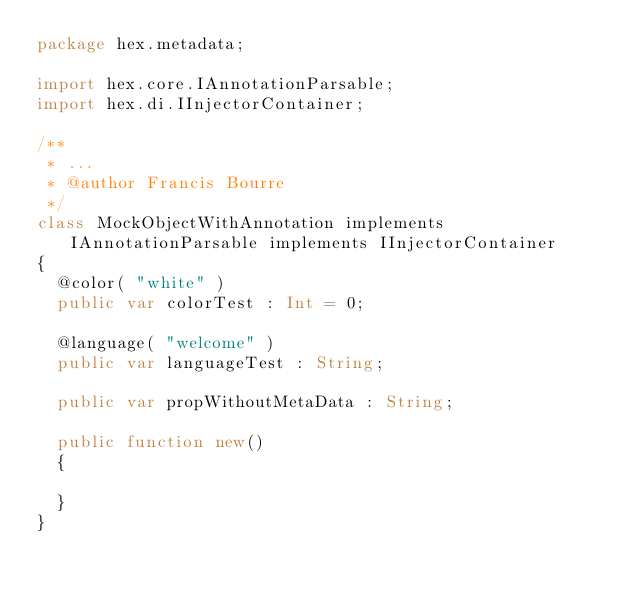<code> <loc_0><loc_0><loc_500><loc_500><_Haxe_>package hex.metadata;

import hex.core.IAnnotationParsable;
import hex.di.IInjectorContainer;

/**
 * ...
 * @author Francis Bourre
 */
class MockObjectWithAnnotation implements IAnnotationParsable implements IInjectorContainer
{
	@color( "white" )
	public var colorTest : Int = 0;

	@language( "welcome" )
	public var languageTest : String;

	public var propWithoutMetaData : String;
		
	public function new() 
	{
		
	}
}</code> 